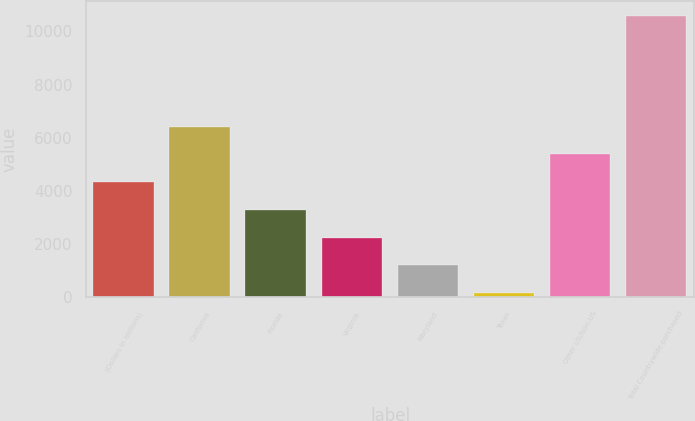Convert chart to OTSL. <chart><loc_0><loc_0><loc_500><loc_500><bar_chart><fcel>(Dollars in millions)<fcel>California<fcel>Florida<fcel>Virginia<fcel>Maryland<fcel>Texas<fcel>Other US/Non-US<fcel>Total Countrywide purchased<nl><fcel>4335.2<fcel>6420.8<fcel>3292.4<fcel>2249.6<fcel>1206.8<fcel>164<fcel>5378<fcel>10592<nl></chart> 